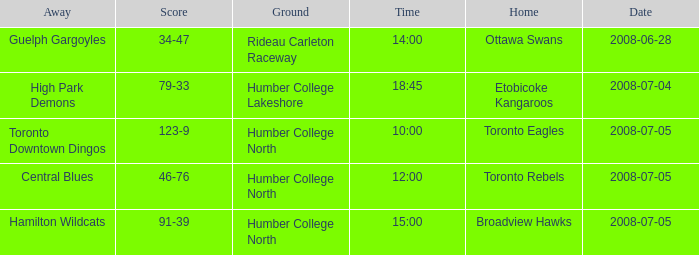What is the Ground with an Away that is central blues? Humber College North. 